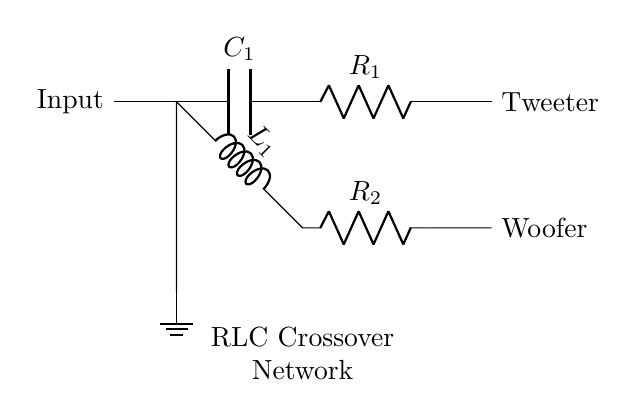What type of circuit is shown? The diagram represents a combination of components designed to separate frequencies for different drivers in a speaker system, specifically identified as an RLC crossover network.
Answer: RLC crossover network What components are used in the high-pass filter? The high-pass filter is composed of a capacitor (C1) followed by a resistor (R1), allowing high frequencies to pass while attenuating low frequencies.
Answer: Capacitor and Resistor How many drivers are in the circuit? The circuit diagram includes two outputs for drivers: one for a tweeter and another for a woofer, indicating that it supports two drivers.
Answer: Two drivers What does the symbol 'L' represent in the circuit? The symbol 'L' in the circuit indicates an inductor, which is used in the low-pass filter to allow low frequencies to pass while blocking high frequencies.
Answer: Inductor What is the outcome at the tweeter? The tweeter is connected to the high-pass filter, which allows only high frequencies to reach it while blocking lower frequencies, enabling optimal sound reproduction for treble.
Answer: High frequencies How does the low-pass filter function in this circuit? The low-pass filter, consisting of an inductor (L1) and a resistor (R2), allows low-frequency signals to pass through to the woofer while attenuating high-frequency signals.
Answer: Attenuates high frequencies 